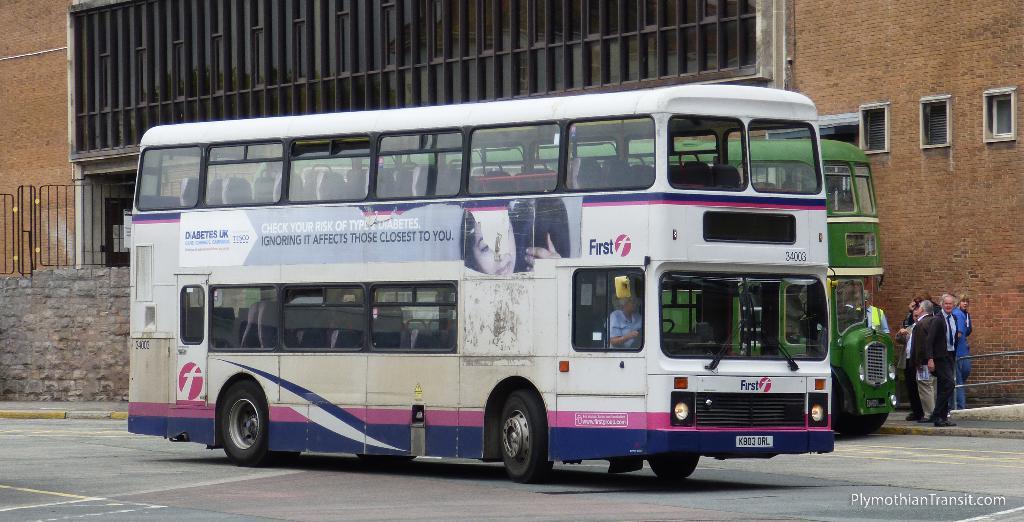What company probably made this bus?
Your answer should be compact. First. What does the tag on the front of the bus say?
Provide a short and direct response. First. 